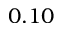Convert formula to latex. <formula><loc_0><loc_0><loc_500><loc_500>0 . 1 0</formula> 